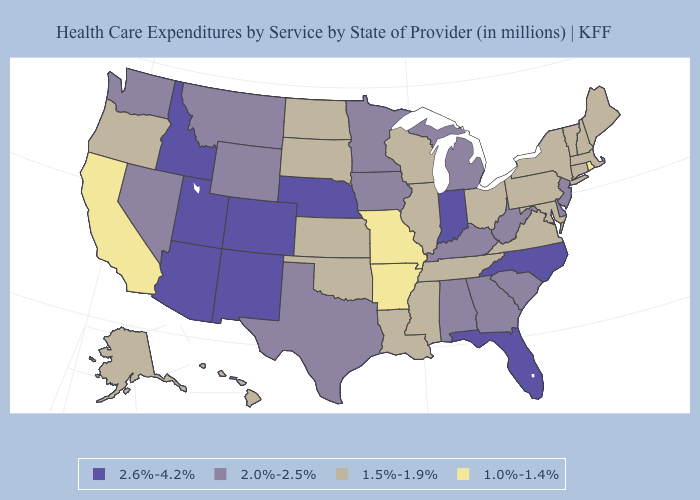Name the states that have a value in the range 1.5%-1.9%?
Be succinct. Alaska, Connecticut, Hawaii, Illinois, Kansas, Louisiana, Maine, Maryland, Massachusetts, Mississippi, New Hampshire, New York, North Dakota, Ohio, Oklahoma, Oregon, Pennsylvania, South Dakota, Tennessee, Vermont, Virginia, Wisconsin. What is the highest value in the USA?
Concise answer only. 2.6%-4.2%. Which states hav the highest value in the Northeast?
Quick response, please. New Jersey. Name the states that have a value in the range 1.0%-1.4%?
Keep it brief. Arkansas, California, Missouri, Rhode Island. What is the value of Arizona?
Quick response, please. 2.6%-4.2%. What is the value of Nevada?
Quick response, please. 2.0%-2.5%. Does Hawaii have the lowest value in the West?
Quick response, please. No. Which states have the lowest value in the MidWest?
Write a very short answer. Missouri. Name the states that have a value in the range 1.0%-1.4%?
Keep it brief. Arkansas, California, Missouri, Rhode Island. What is the value of Delaware?
Answer briefly. 2.0%-2.5%. Does Oklahoma have a higher value than Rhode Island?
Answer briefly. Yes. Does the map have missing data?
Answer briefly. No. Name the states that have a value in the range 2.6%-4.2%?
Keep it brief. Arizona, Colorado, Florida, Idaho, Indiana, Nebraska, New Mexico, North Carolina, Utah. Which states have the lowest value in the USA?
Give a very brief answer. Arkansas, California, Missouri, Rhode Island. Name the states that have a value in the range 1.0%-1.4%?
Keep it brief. Arkansas, California, Missouri, Rhode Island. 